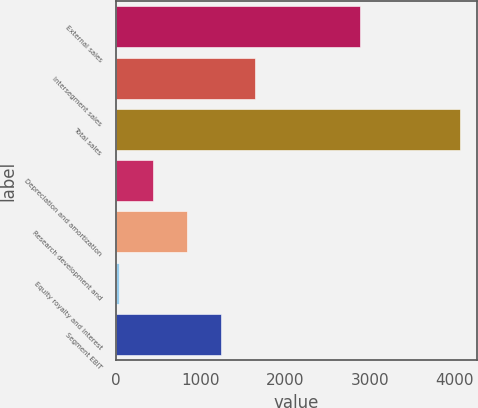<chart> <loc_0><loc_0><loc_500><loc_500><bar_chart><fcel>External sales<fcel>Intersegment sales<fcel>Total sales<fcel>Depreciation and amortization<fcel>Research development and<fcel>Equity royalty and interest<fcel>Segment EBIT<nl><fcel>2886<fcel>1643.8<fcel>4063<fcel>434.2<fcel>837.4<fcel>31<fcel>1240.6<nl></chart> 